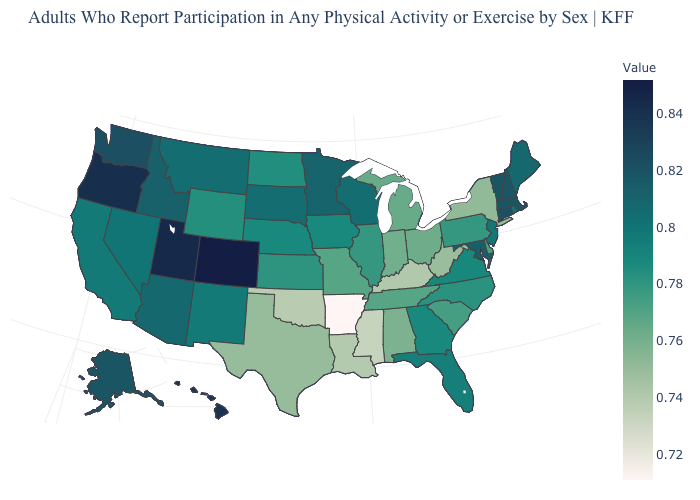Which states have the highest value in the USA?
Answer briefly. Colorado. Does Minnesota have the highest value in the MidWest?
Be succinct. Yes. Among the states that border Ohio , which have the lowest value?
Answer briefly. Kentucky. Which states have the lowest value in the West?
Quick response, please. Wyoming. 